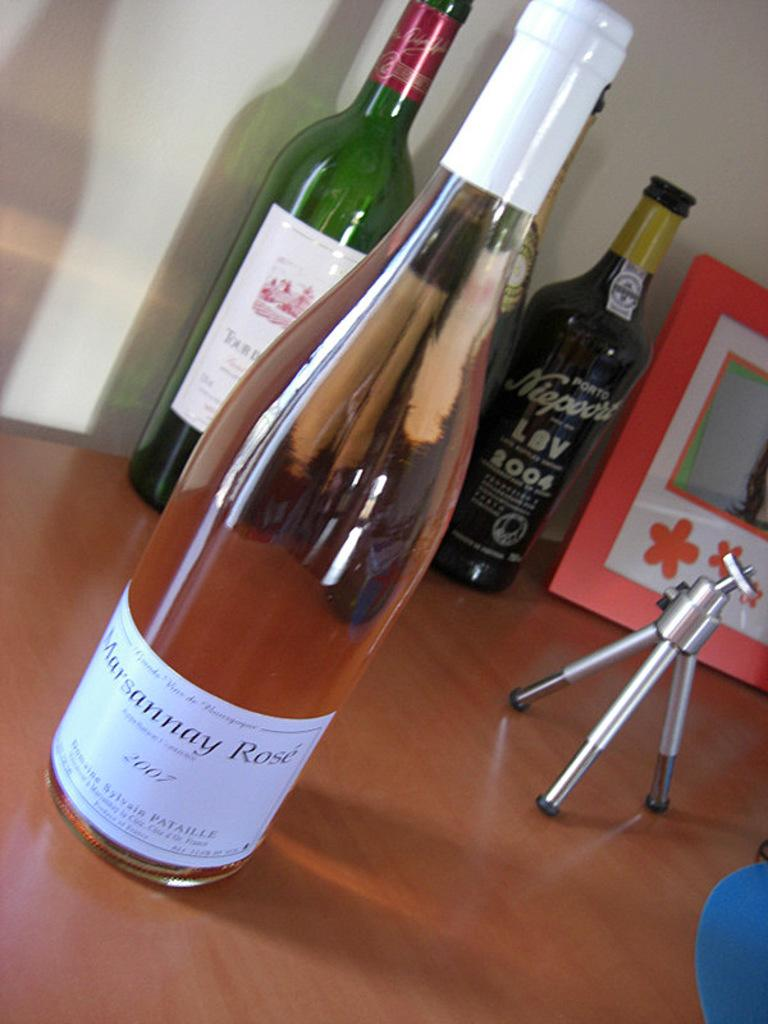<image>
Offer a succinct explanation of the picture presented. A bottle of Marsannay Rose from 2007 sits in front of some other wine bottles. 